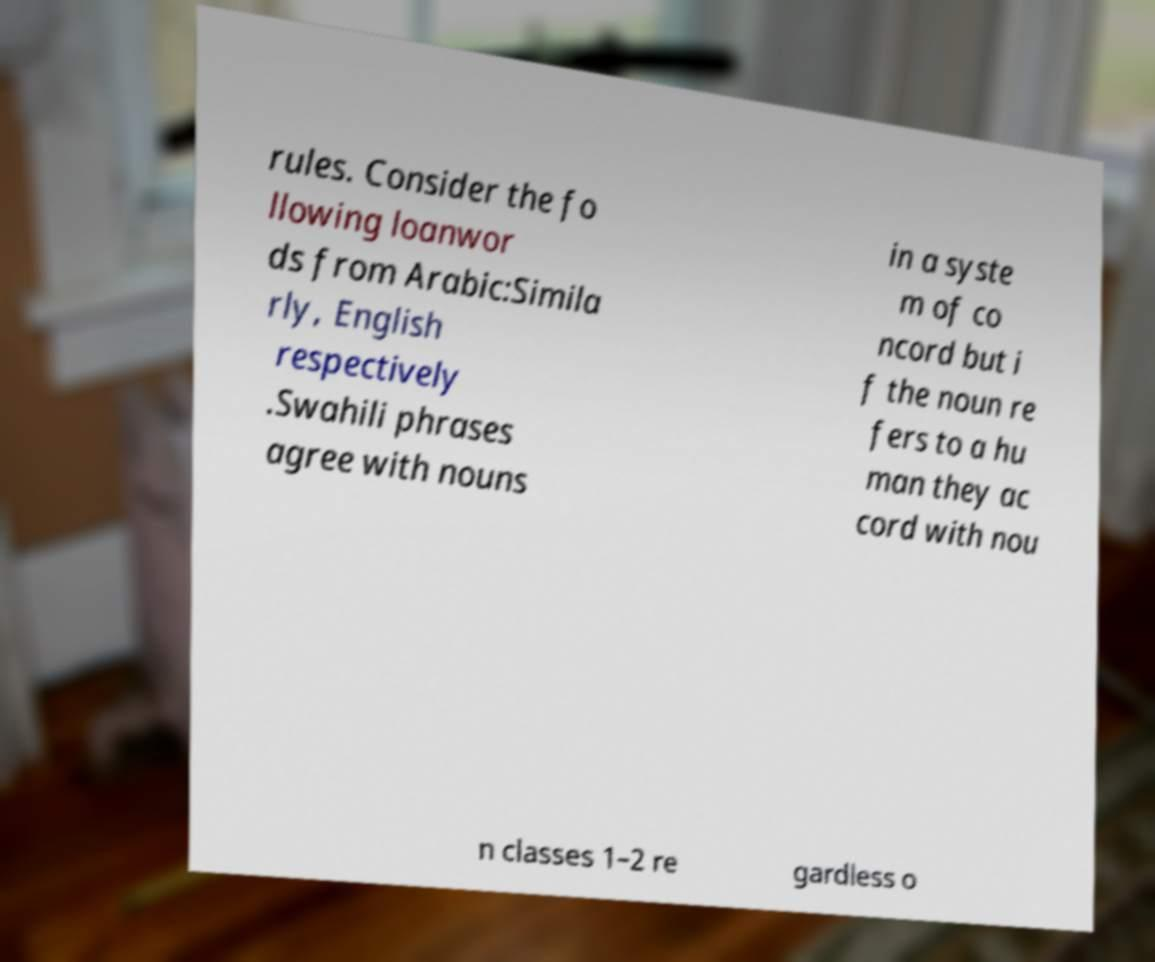For documentation purposes, I need the text within this image transcribed. Could you provide that? rules. Consider the fo llowing loanwor ds from Arabic:Simila rly, English respectively .Swahili phrases agree with nouns in a syste m of co ncord but i f the noun re fers to a hu man they ac cord with nou n classes 1–2 re gardless o 